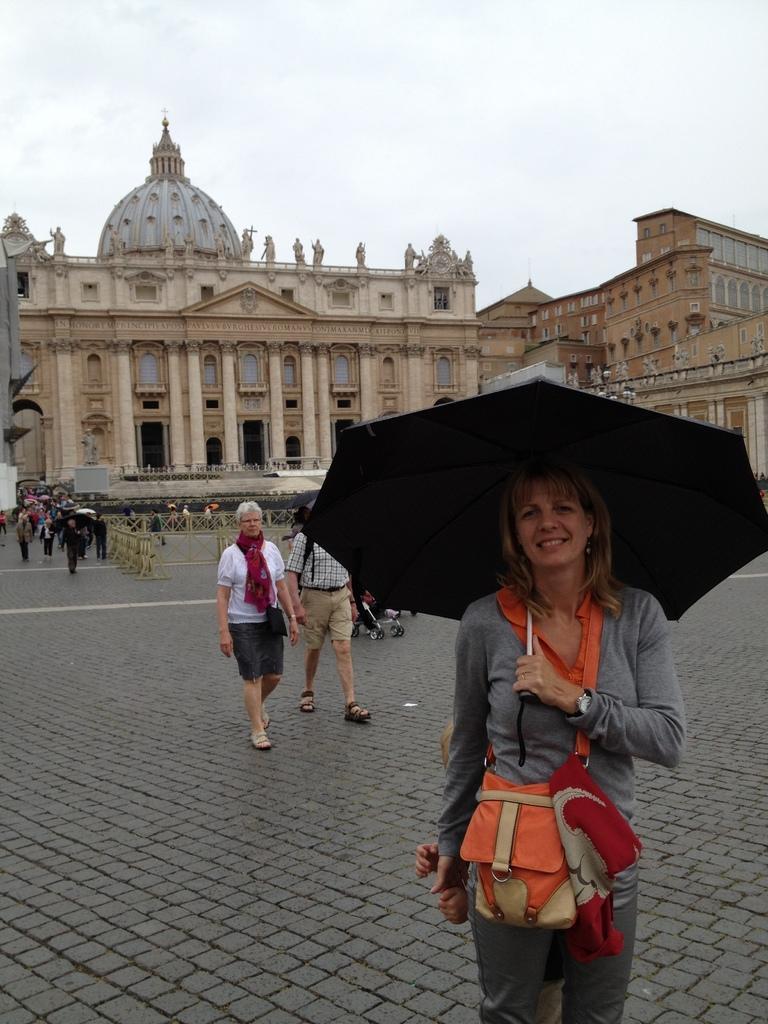Please provide a concise description of this image. In this image we can see a few people on the floor, some of them are walking and a woman is holding an umbrella and in the background there is a building, iron railing and sky. 